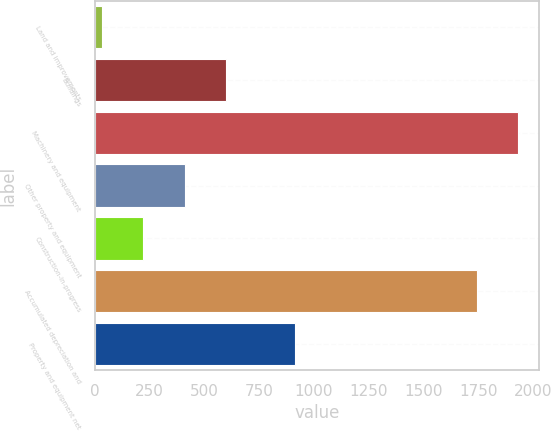Convert chart. <chart><loc_0><loc_0><loc_500><loc_500><bar_chart><fcel>Land and improvements<fcel>Buildings<fcel>Machinery and equipment<fcel>Other property and equipment<fcel>Construction-in-progress<fcel>Accumulated depreciation and<fcel>Property and equipment net<nl><fcel>32.8<fcel>598.27<fcel>1929.99<fcel>409.78<fcel>221.29<fcel>1741.5<fcel>911.2<nl></chart> 